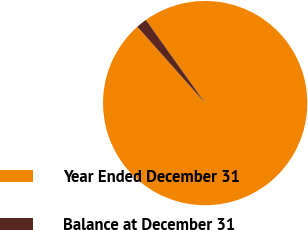<chart> <loc_0><loc_0><loc_500><loc_500><pie_chart><fcel>Year Ended December 31<fcel>Balance at December 31<nl><fcel>98.29%<fcel>1.71%<nl></chart> 